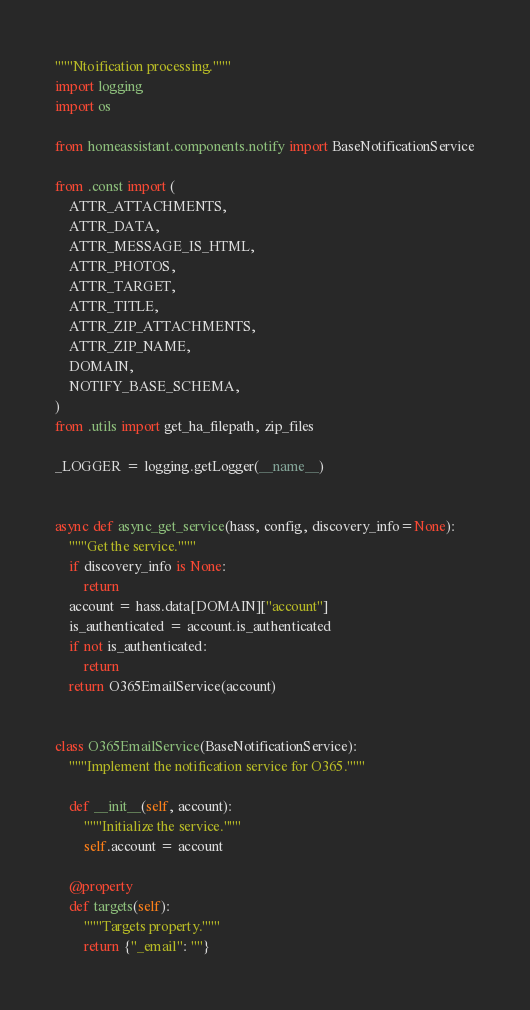Convert code to text. <code><loc_0><loc_0><loc_500><loc_500><_Python_>"""Ntoification processing."""
import logging
import os

from homeassistant.components.notify import BaseNotificationService

from .const import (
    ATTR_ATTACHMENTS,
    ATTR_DATA,
    ATTR_MESSAGE_IS_HTML,
    ATTR_PHOTOS,
    ATTR_TARGET,
    ATTR_TITLE,
    ATTR_ZIP_ATTACHMENTS,
    ATTR_ZIP_NAME,
    DOMAIN,
    NOTIFY_BASE_SCHEMA,
)
from .utils import get_ha_filepath, zip_files

_LOGGER = logging.getLogger(__name__)


async def async_get_service(hass, config, discovery_info=None):
    """Get the service."""
    if discovery_info is None:
        return
    account = hass.data[DOMAIN]["account"]
    is_authenticated = account.is_authenticated
    if not is_authenticated:
        return
    return O365EmailService(account)


class O365EmailService(BaseNotificationService):
    """Implement the notification service for O365."""

    def __init__(self, account):
        """Initialize the service."""
        self.account = account

    @property
    def targets(self):
        """Targets property."""
        return {"_email": ""}
</code> 